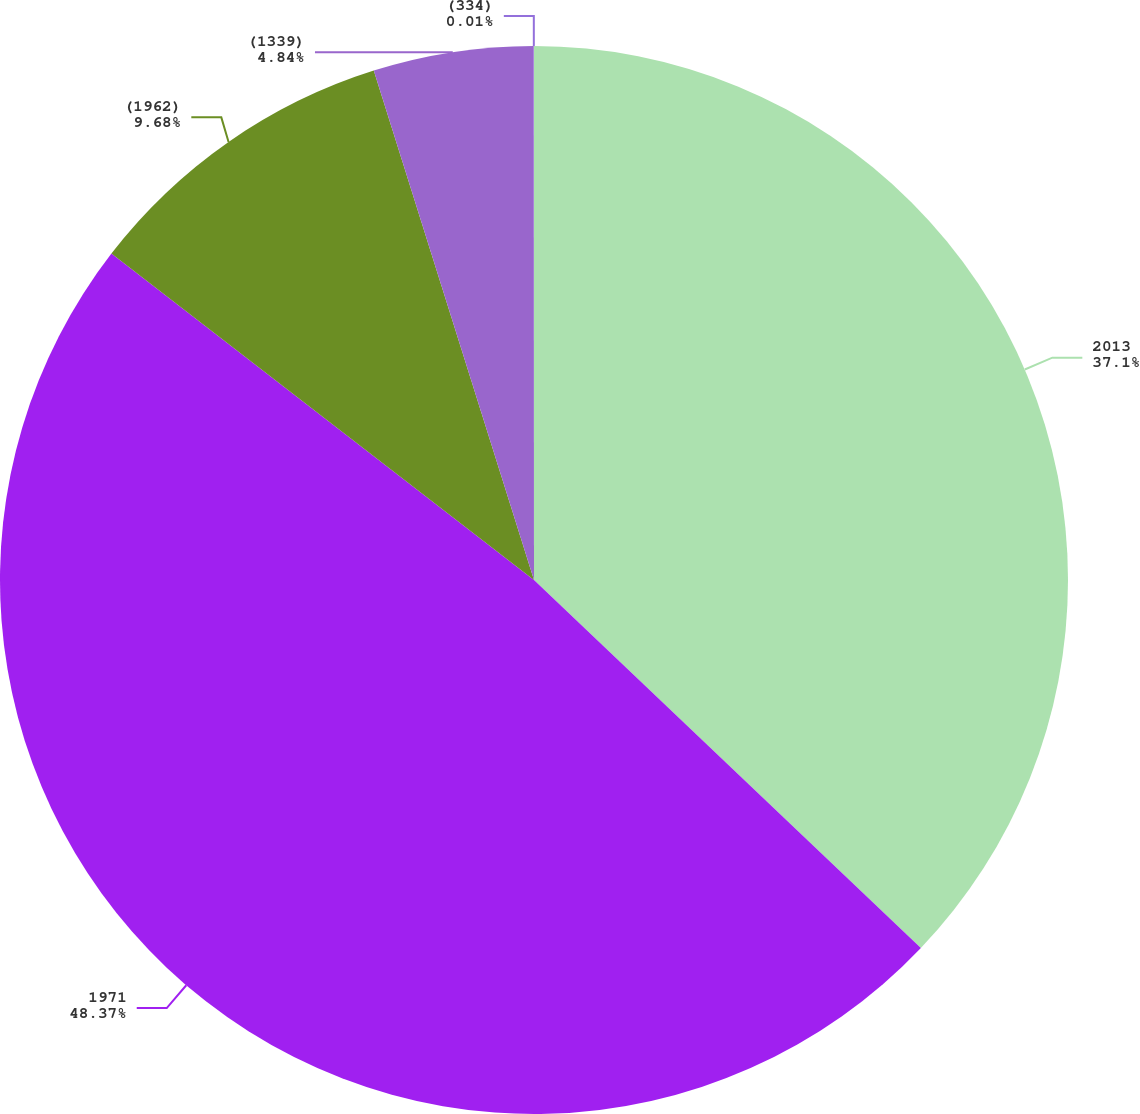Convert chart. <chart><loc_0><loc_0><loc_500><loc_500><pie_chart><fcel>2013<fcel>1971<fcel>(1962)<fcel>(1339)<fcel>(334)<nl><fcel>37.1%<fcel>48.36%<fcel>9.68%<fcel>4.84%<fcel>0.01%<nl></chart> 